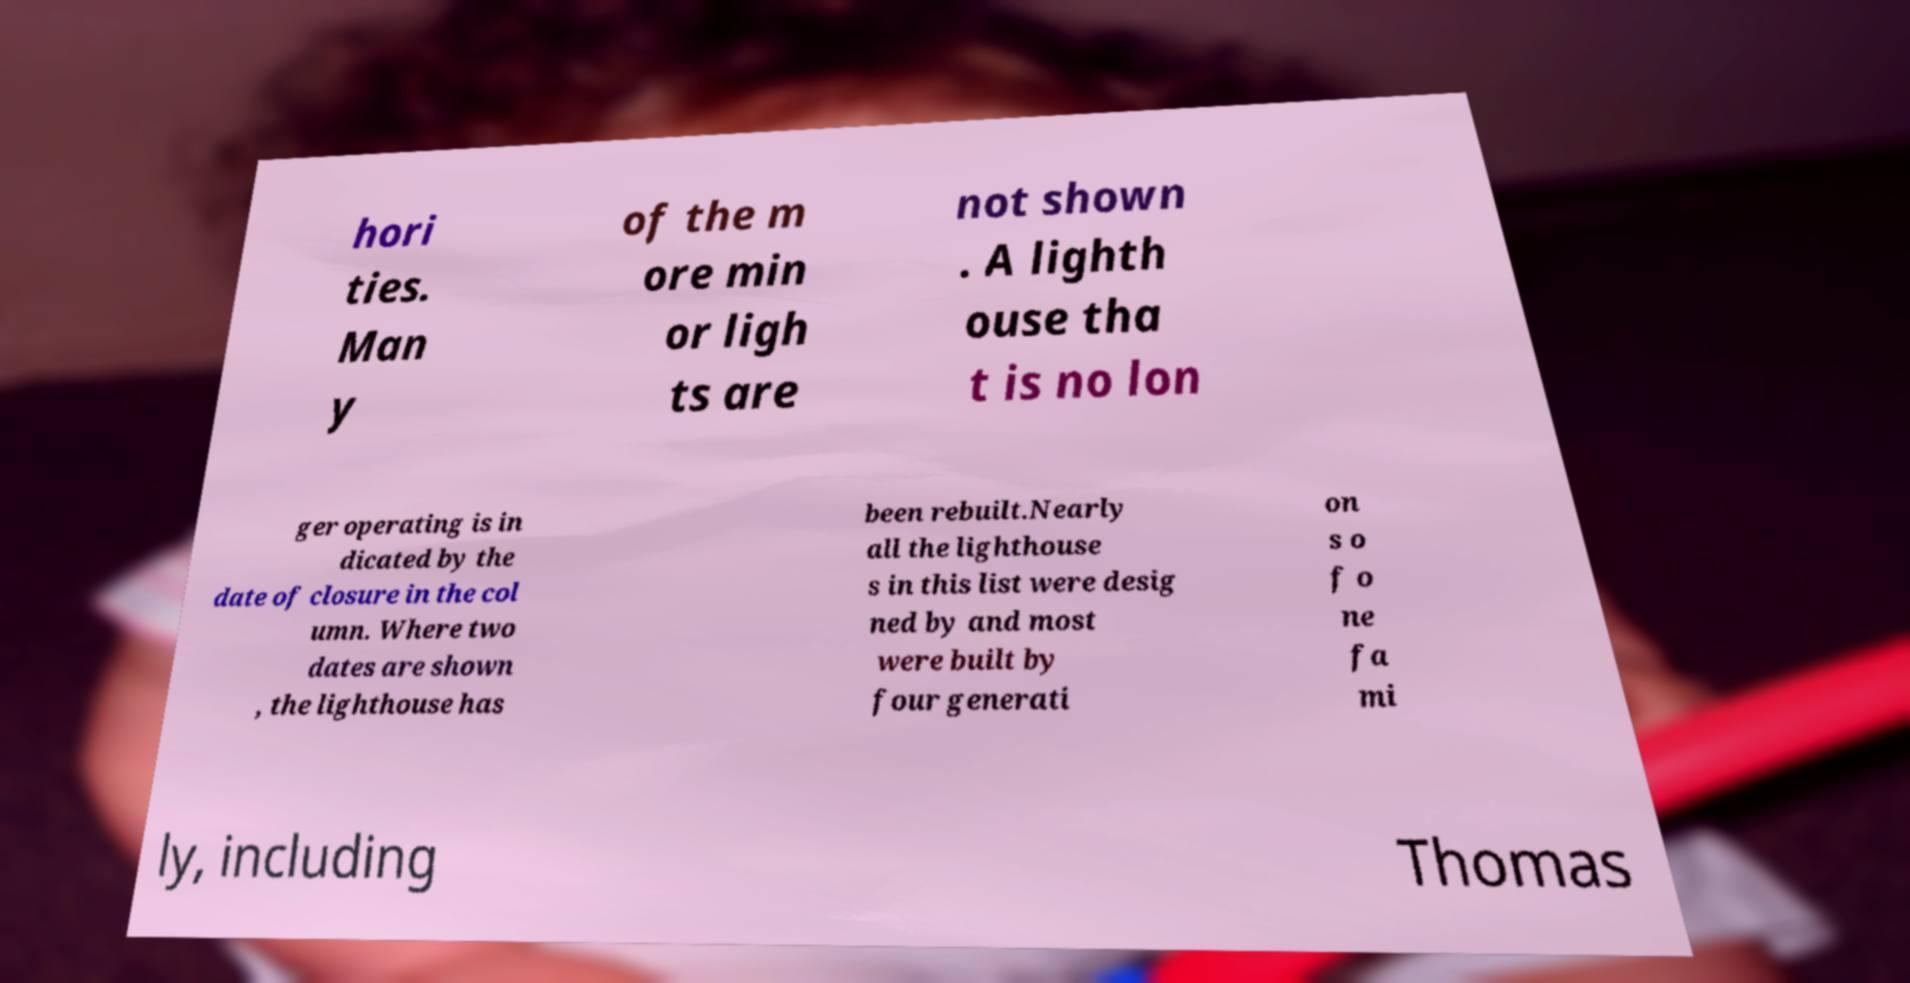Please read and relay the text visible in this image. What does it say? hori ties. Man y of the m ore min or ligh ts are not shown . A lighth ouse tha t is no lon ger operating is in dicated by the date of closure in the col umn. Where two dates are shown , the lighthouse has been rebuilt.Nearly all the lighthouse s in this list were desig ned by and most were built by four generati on s o f o ne fa mi ly, including Thomas 